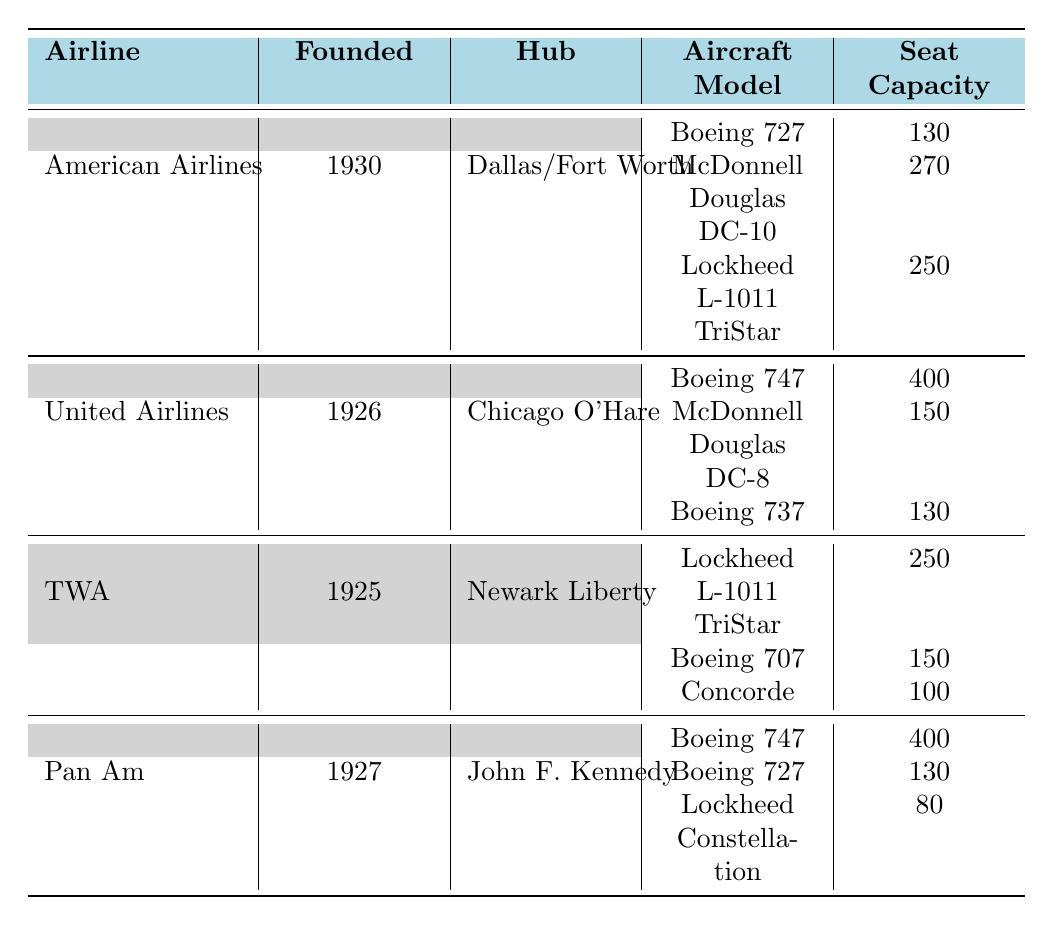What is the hub of TWA? The table lists each airline's hub under the "Hub" column. For TWA, which is in the first column under its name, the corresponding hub is "Newark Liberty International Airport".
Answer: Newark Liberty International Airport What is the seat capacity of the Boeing 747 operated by Pan Am? To find this, look under the "Aircraft Model" column for Pan Am, find the row with "Boeing 747," and check the corresponding "Seat Capacity" value, which is listed as 400.
Answer: 400 Which airline's fleet includes the McDonnell Douglas DC-10? The table displays the fleet for each airline. Searching for "McDonnell Douglas DC-10" within the fleet section, we find it under American Airlines, indicating that this airline operates this model.
Answer: American Airlines How many aircraft models did United Airlines have in the 1970s? By examining the rows for United Airlines, we can count the aircraft models listed, which are Boeing 747, McDonnell Douglas DC-8, and Boeing 737, totaling three different aircraft models.
Answer: 3 Did any airline operate the Concorde in the 1970s? Looking through the airlines listed, the Concorde is shown as part of TWA's fleet, confirming that it was indeed operated by an airline during the 1970s.
Answer: Yes What is the average seating capacity for American Airlines' fleet? First, we will find the seating capacities listed for American Airlines: 130 (Boeing 727), 270 (McDonnell Douglas DC-10), and 250 (Lockheed L-1011 TriStar). Adding these values gives 130 + 270 + 250 = 650. There are three models, so the average is 650 / 3 = approximately 216.67.
Answer: Approximately 216.67 Which airline, founded in 1925, used the Lockheed L-1011 TriStar? Among the airlines listed, TWA, which is founded in 1925, operates the Lockheed L-1011 TriStar as shown in its fleet section.
Answer: TWA What is the difference in seating capacity between the Boeing 747 and the Boeing 727 for Pan Am? Pan Am operates the Boeing 747 with a seating capacity of 400 and the Boeing 727 with a capacity of 130. The difference can be calculated as 400 - 130 = 270.
Answer: 270 Which airline was established first: United Airlines or American Airlines? To determine this, we compare their founding years listed in the table: United Airlines was founded in 1926, while American Airlines was founded in 1930. Since 1926 is earlier than 1930, United Airlines was established first.
Answer: United Airlines 